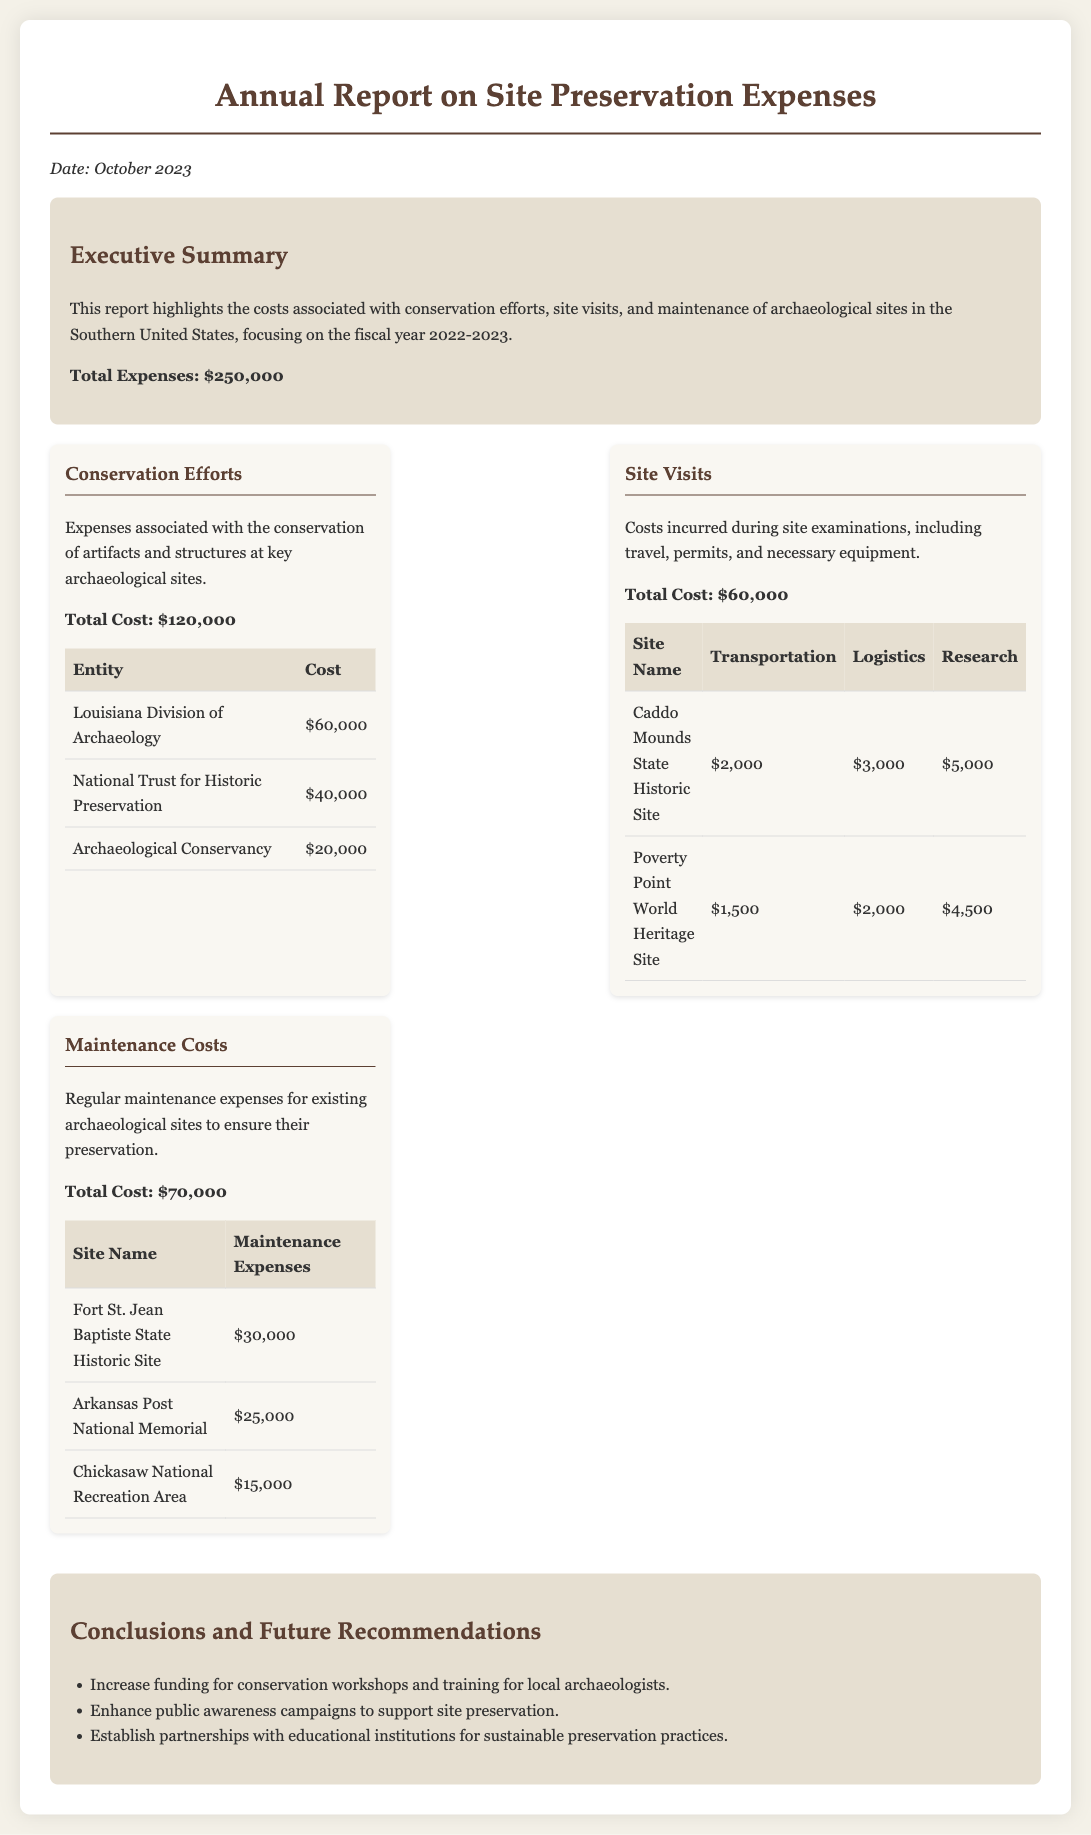what is the total cost of site visits? The total cost of site visits is explicitly listed in the document as $60,000.
Answer: $60,000 who contributed the most to conservation efforts? The entity that contributed the most to conservation efforts is the Louisiana Division of Archaeology, with a cost of $60,000.
Answer: Louisiana Division of Archaeology what was the total expense for maintenance costs? The document specifies the total expense for maintenance costs as $70,000.
Answer: $70,000 how much was spent on site visits for the Caddo Mounds State Historic Site? The document lists the costs for the Caddo Mounds State Historic Site including transportation, logistics, and research, totaling $10,000.
Answer: $10,000 what recommendation is made regarding public awareness? The report recommends enhancing public awareness campaigns to support site preservation.
Answer: Enhance public awareness campaigns what is the total expense reported in the executive summary? The total expense reported in the executive summary is $250,000.
Answer: $250,000 which organization had a conservation cost of $40,000? The organization that had a conservation cost of $40,000 is the National Trust for Historic Preservation.
Answer: National Trust for Historic Preservation what was the maintenance expense at the Arkansas Post National Memorial? The document lists the maintenance expense at the Arkansas Post National Memorial as $25,000.
Answer: $25,000 what is a key focus area of the report? The report focuses specifically on conservation efforts, site visits, and maintenance at archaeological sites.
Answer: Conservation efforts 